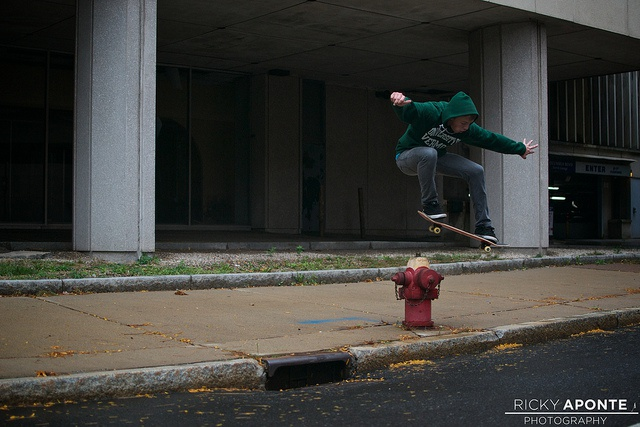Describe the objects in this image and their specific colors. I can see people in black, teal, and gray tones, fire hydrant in black, maroon, gray, and brown tones, and skateboard in black, gray, darkgray, and maroon tones in this image. 